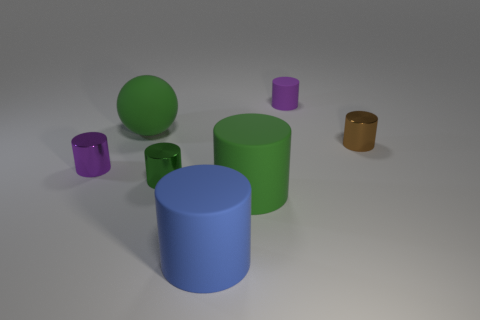Subtract all tiny cylinders. How many cylinders are left? 2 Add 1 green objects. How many objects exist? 8 Subtract all blue cylinders. How many cylinders are left? 5 Subtract all balls. How many objects are left? 6 Add 3 small purple rubber things. How many small purple rubber things exist? 4 Subtract 2 green cylinders. How many objects are left? 5 Subtract 1 spheres. How many spheres are left? 0 Subtract all yellow cylinders. Subtract all blue blocks. How many cylinders are left? 6 Subtract all blue cylinders. How many purple balls are left? 0 Subtract all matte cylinders. Subtract all small yellow metal things. How many objects are left? 4 